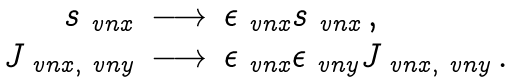Convert formula to latex. <formula><loc_0><loc_0><loc_500><loc_500>\begin{array} { r c l } s _ { \ v n { x } } & \longrightarrow & \epsilon _ { \ v n { x } } s _ { \ v n { x } } \, , \\ J _ { { \ v n { x } } , { \ v n { y } } } & \longrightarrow & \epsilon _ { \ v n { x } } \epsilon _ { \ v n { y } } J _ { { \ v n { x } } , { \ v n { y } } } \, . \end{array}</formula> 